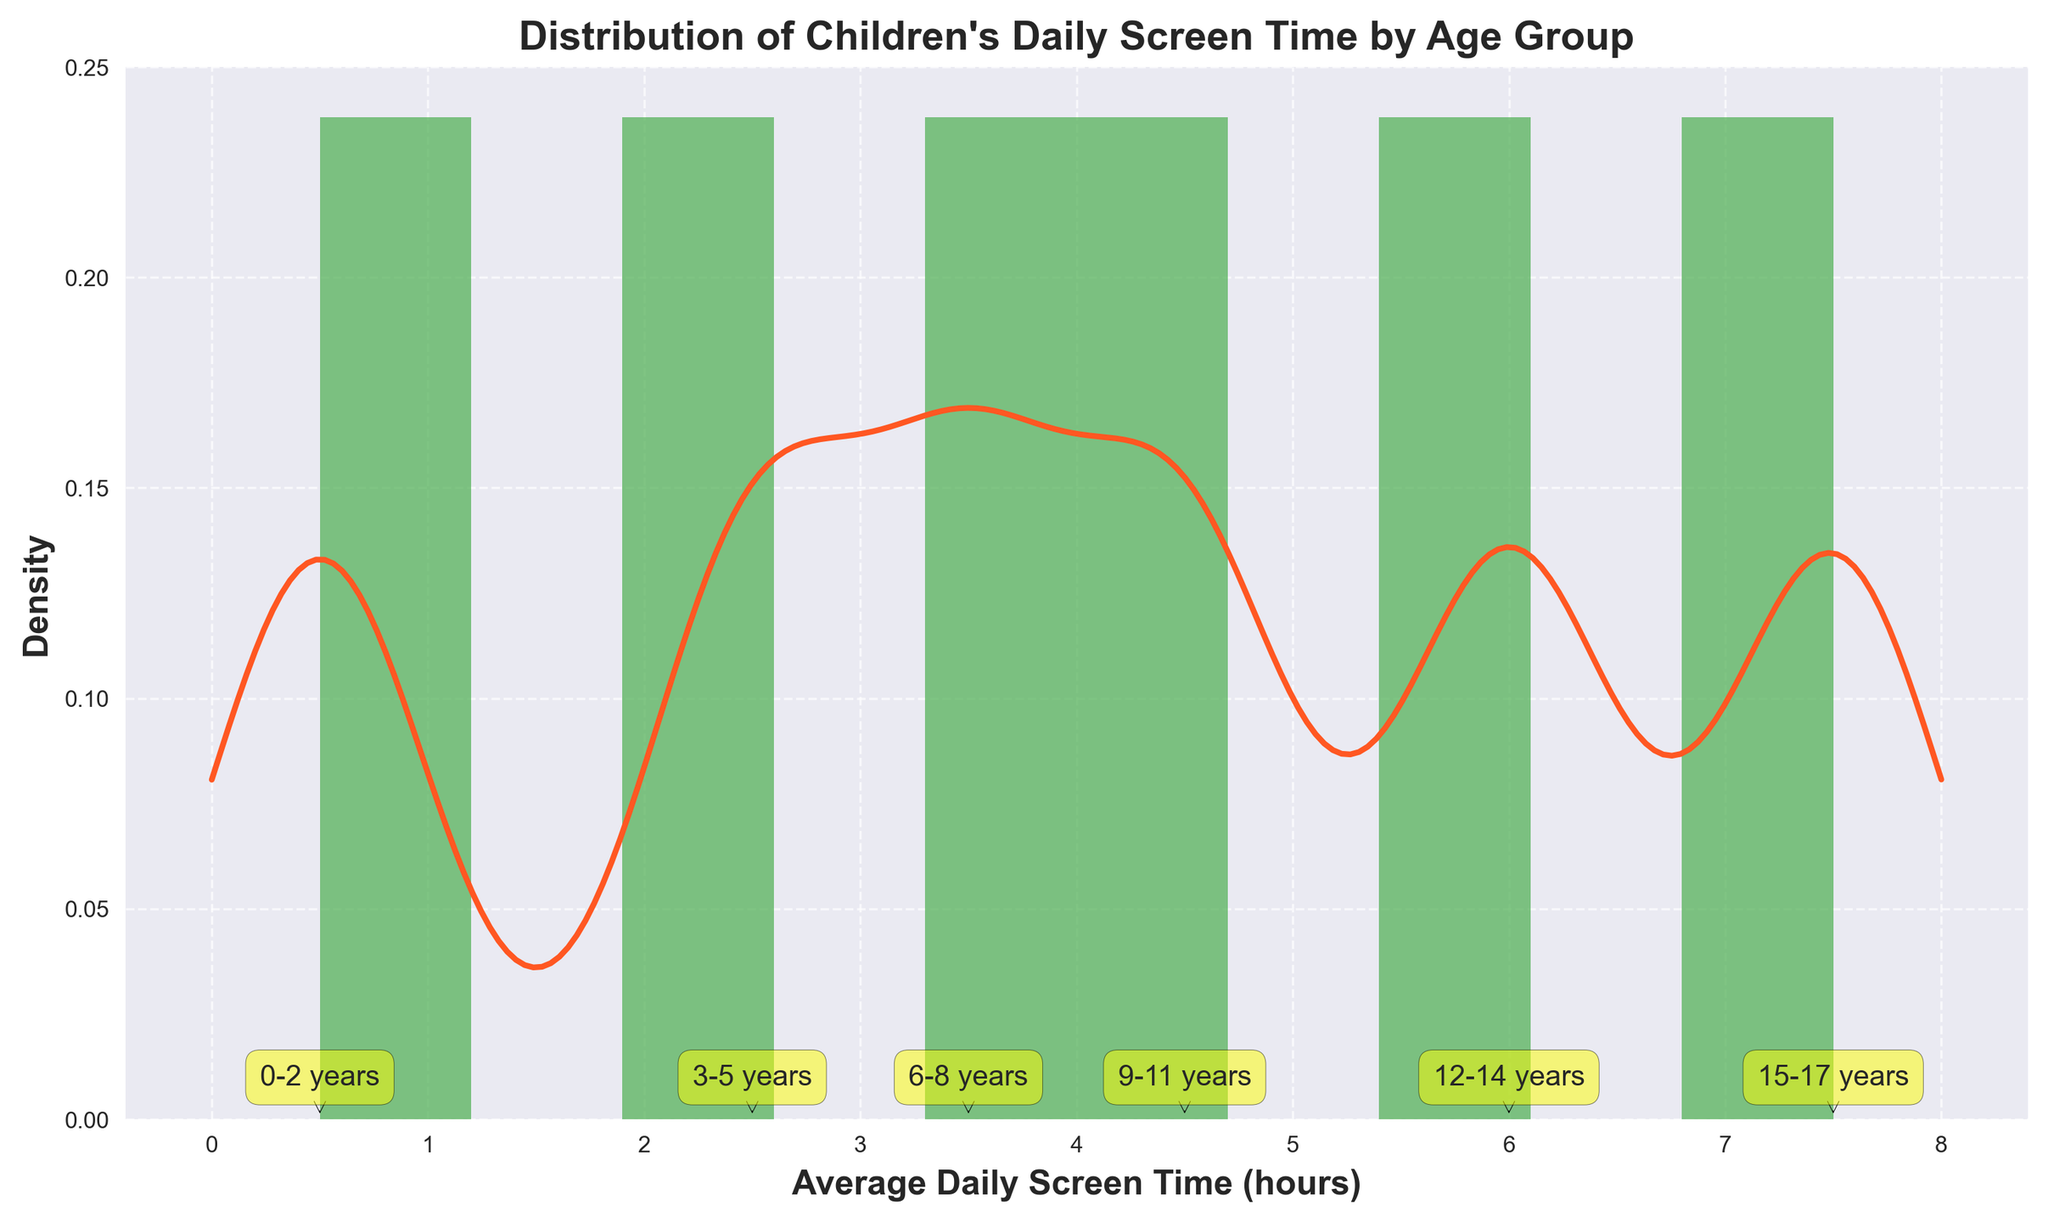What does the x-axis represent? The x-axis represents the average daily screen time in hours spent by children of various age groups. This is indicated by the label on the x-axis.
Answer: Average Daily Screen Time (hours) What is the highest average daily screen time recorded, and which age group does it belong to? The highest average daily screen time recorded is 7.5 hours, and it belongs to the 15-17 years age group. This is shown by the data points and corresponding labels on the histogram.
Answer: 7.5 hours, 15-17 years How many age groups are displayed in the histogram? By counting the distinct labels present in the histogram, we can see that there are six age groups displayed. Each age group has a unique label marked on the data points.
Answer: Six Between which hours does the KDE curve show the highest density? The KDE curve reaches its peak height at around 4 to 5 hours on the x-axis. This indicates the period where the density is highest.
Answer: Around 4 to 5 hours Which age group has the lowest average daily screen time, and what is the value? The 0-2 years age group has the lowest average daily screen time, with a value of 0.5 hours. This is observed from the first data point in the histogram that is annotated.
Answer: 0-2 years, 0.5 hours What is the approximate average screen time for the middle three age groups combined (6-8 years, 9-11 years, 12-14 years)? First, sum the average screen times for the three age groups: 3.5 + 4.5 + 6.0 = 14. Then, divide by 3 to find the average: 14 / 3 ≈ 4.67 hours.
Answer: ≈ 4.67 hours Is the distribution of daily screen time symmetric? The KDE curve shows that the distribution is skewed to the right, meaning more children have higher screen times as indicated by the right-sided tail of the curve.
Answer: No How does the average screen time of 12-14-year-olds compare to that of 6-8-year-olds? The average screen time for 12-14 year-olds is 6.0 hours, while for 6-8 year-olds it is 3.5 hours. The 12-14 year-olds have a higher average screen time.
Answer: Higher What can be inferred about the trend in screen time as children grow older? Observing the histogram, there is a clear increasing trend in the average daily screen time as the age groups progress from 0-2 years up to 15-17 years.
Answer: It increases At approximately what screen time value does the KDE curve start to decline? The KDE curve starts to decline at around 5 hours on the x-axis. This marks the point where the density of children’s screen time begins to decrease.
Answer: Around 5 hours 